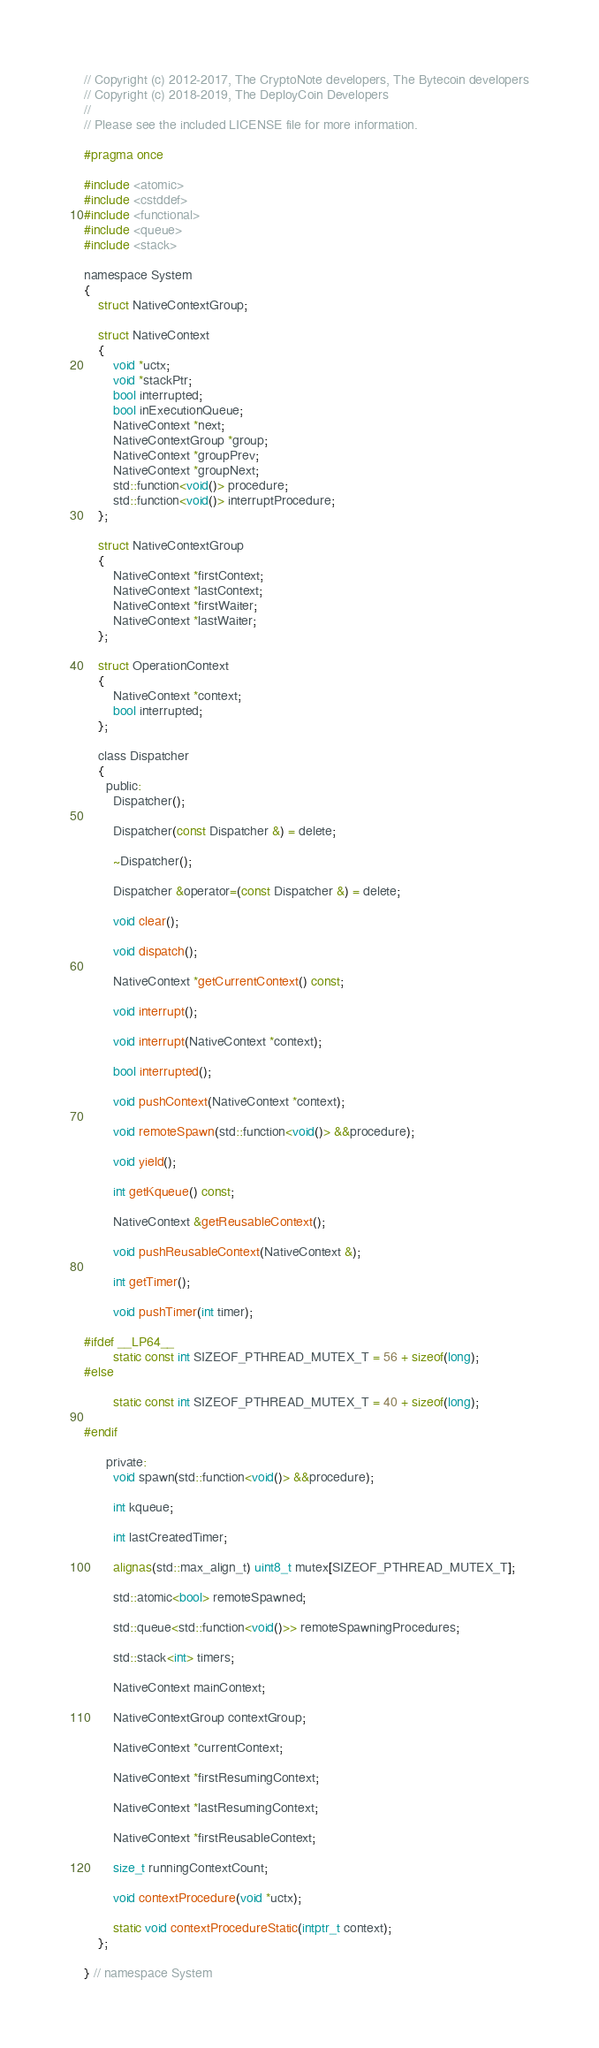<code> <loc_0><loc_0><loc_500><loc_500><_C_>// Copyright (c) 2012-2017, The CryptoNote developers, The Bytecoin developers
// Copyright (c) 2018-2019, The DeployCoin Developers
//
// Please see the included LICENSE file for more information.

#pragma once

#include <atomic>
#include <cstddef>
#include <functional>
#include <queue>
#include <stack>

namespace System
{
    struct NativeContextGroup;

    struct NativeContext
    {
        void *uctx;
        void *stackPtr;
        bool interrupted;
        bool inExecutionQueue;
        NativeContext *next;
        NativeContextGroup *group;
        NativeContext *groupPrev;
        NativeContext *groupNext;
        std::function<void()> procedure;
        std::function<void()> interruptProcedure;
    };

    struct NativeContextGroup
    {
        NativeContext *firstContext;
        NativeContext *lastContext;
        NativeContext *firstWaiter;
        NativeContext *lastWaiter;
    };

    struct OperationContext
    {
        NativeContext *context;
        bool interrupted;
    };

    class Dispatcher
    {
      public:
        Dispatcher();

        Dispatcher(const Dispatcher &) = delete;

        ~Dispatcher();

        Dispatcher &operator=(const Dispatcher &) = delete;

        void clear();

        void dispatch();

        NativeContext *getCurrentContext() const;

        void interrupt();

        void interrupt(NativeContext *context);

        bool interrupted();

        void pushContext(NativeContext *context);

        void remoteSpawn(std::function<void()> &&procedure);

        void yield();

        int getKqueue() const;

        NativeContext &getReusableContext();

        void pushReusableContext(NativeContext &);

        int getTimer();

        void pushTimer(int timer);

#ifdef __LP64__
        static const int SIZEOF_PTHREAD_MUTEX_T = 56 + sizeof(long);
#else

        static const int SIZEOF_PTHREAD_MUTEX_T = 40 + sizeof(long);

#endif

      private:
        void spawn(std::function<void()> &&procedure);

        int kqueue;

        int lastCreatedTimer;

        alignas(std::max_align_t) uint8_t mutex[SIZEOF_PTHREAD_MUTEX_T];

        std::atomic<bool> remoteSpawned;

        std::queue<std::function<void()>> remoteSpawningProcedures;

        std::stack<int> timers;

        NativeContext mainContext;

        NativeContextGroup contextGroup;

        NativeContext *currentContext;

        NativeContext *firstResumingContext;

        NativeContext *lastResumingContext;

        NativeContext *firstReusableContext;

        size_t runningContextCount;

        void contextProcedure(void *uctx);

        static void contextProcedureStatic(intptr_t context);
    };

} // namespace System
</code> 